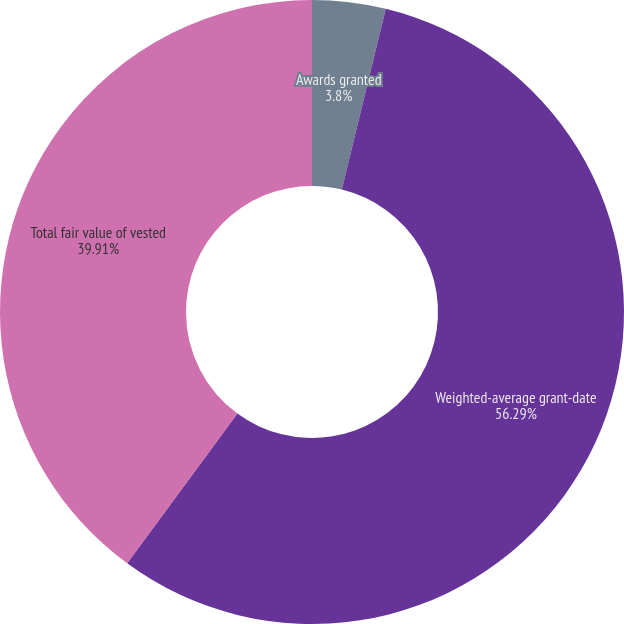Convert chart. <chart><loc_0><loc_0><loc_500><loc_500><pie_chart><fcel>Awards granted<fcel>Weighted-average grant-date<fcel>Total fair value of vested<nl><fcel>3.8%<fcel>56.29%<fcel>39.91%<nl></chart> 